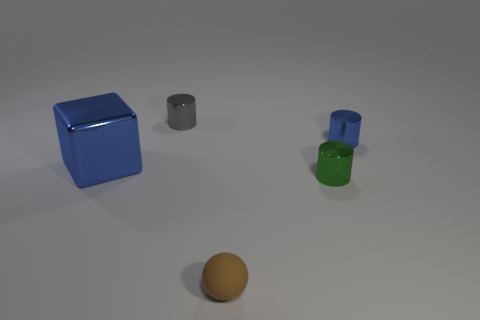Subtract all tiny blue cylinders. How many cylinders are left? 2 Subtract all green cylinders. How many cylinders are left? 2 Add 3 tiny brown spheres. How many objects exist? 8 Subtract all spheres. How many objects are left? 4 Add 2 tiny gray things. How many tiny gray things exist? 3 Subtract 0 purple cylinders. How many objects are left? 5 Subtract 2 cylinders. How many cylinders are left? 1 Subtract all cyan cylinders. Subtract all cyan balls. How many cylinders are left? 3 Subtract all yellow spheres. How many blue cylinders are left? 1 Subtract all green matte balls. Subtract all tiny green objects. How many objects are left? 4 